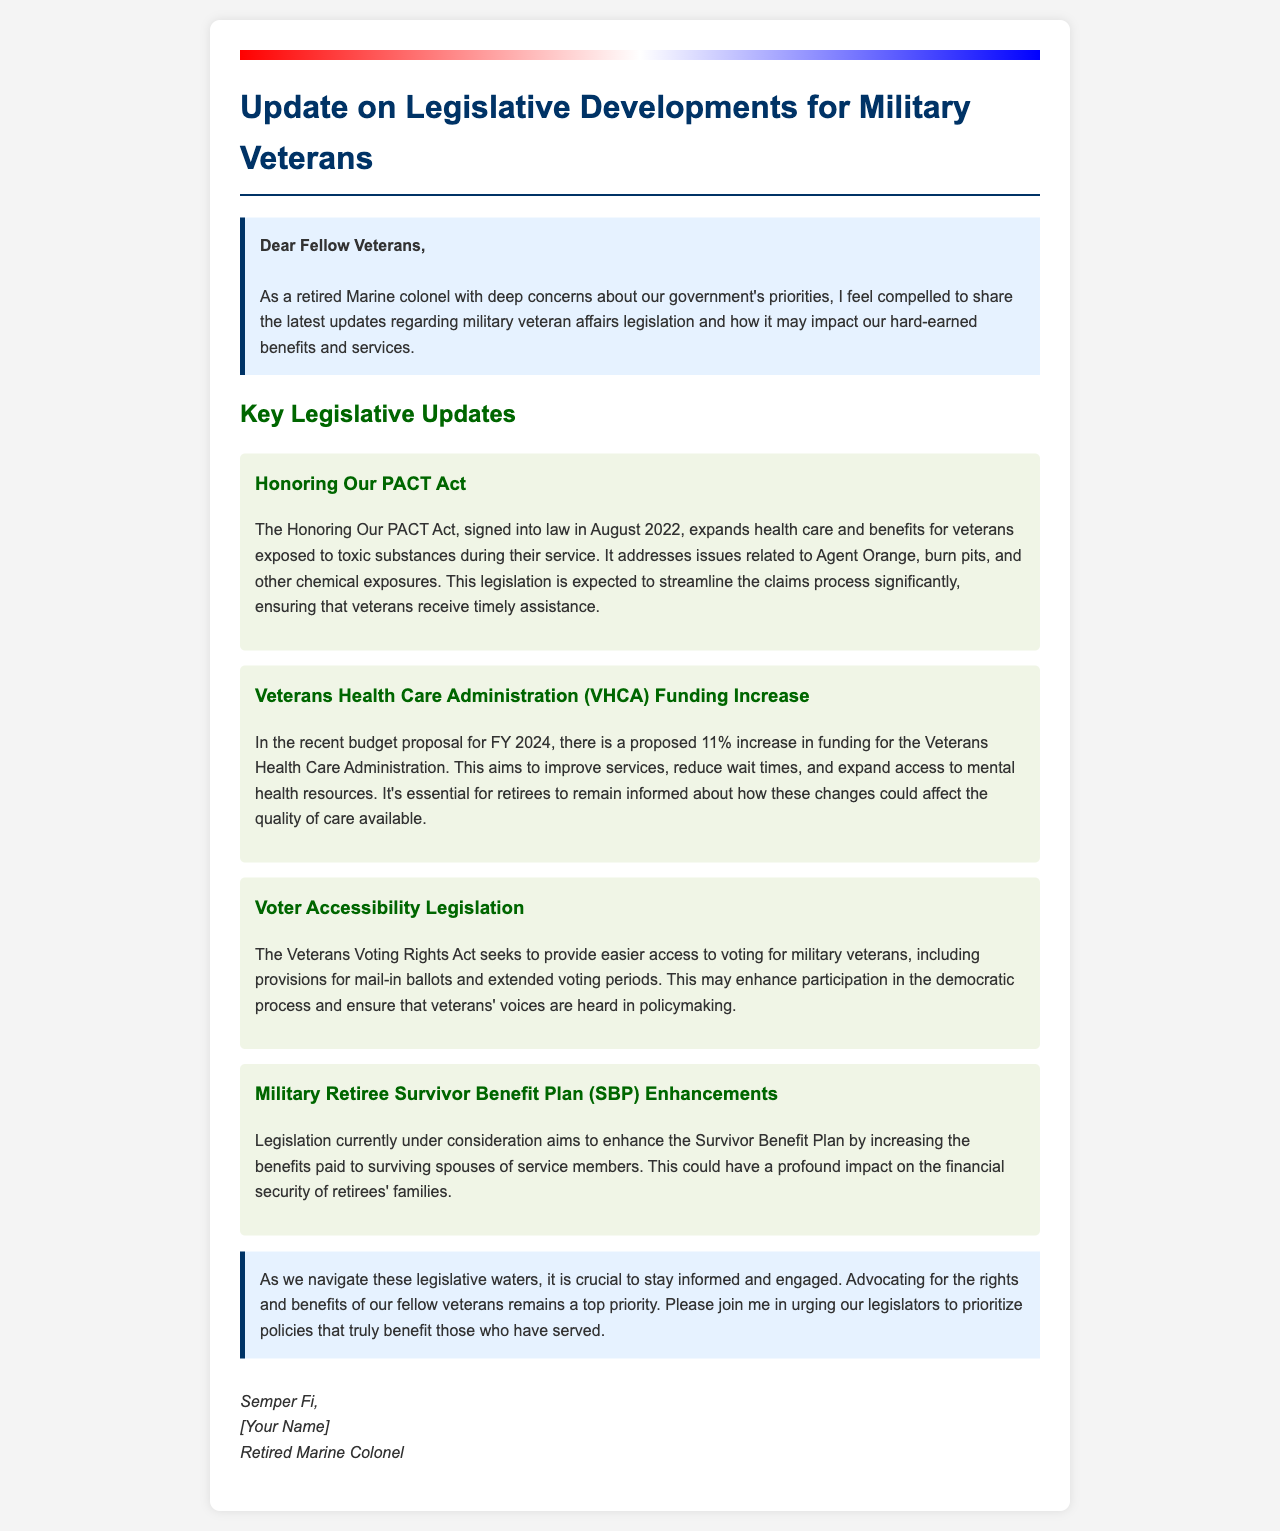What is the title of the document? The title of the document is stated at the beginning, which is "Update on Legislative Developments for Military Veterans."
Answer: Update on Legislative Developments for Military Veterans What act is mentioned in the document that expands health care for veterans? The act mentioned is specified in the legislative updates section, which is the "Honoring Our PACT Act."
Answer: Honoring Our PACT Act What is the proposed funding increase for the Veterans Health Care Administration in FY 2024? The proposed funding increase is indicated in the budget proposal section as "11%."
Answer: 11% What does the Veterans Voting Rights Act aim to provide? The document states that the Veterans Voting Rights Act seeks to provide "easier access to voting for military veterans."
Answer: easier access to voting for military veterans What benefit could the proposed legislation on the Survivor Benefit Plan affect? The legislation under consideration aims to enhance the "Survivor Benefit Plan" for surviving spouses.
Answer: Survivor Benefit Plan What is a recurring theme in the document regarding legislative priorities? The document emphasizes the need for "advocating for the rights and benefits of our fellow veterans."
Answer: advocating for the rights and benefits of our fellow veterans Who authored the document? The author is identified at the end of the document as a "Retired Marine Colonel."
Answer: Retired Marine Colonel What color is used for the flag background in the document? The flag background is described as having a gradient of colors, which includes "red, white, and blue."
Answer: red, white, and blue 